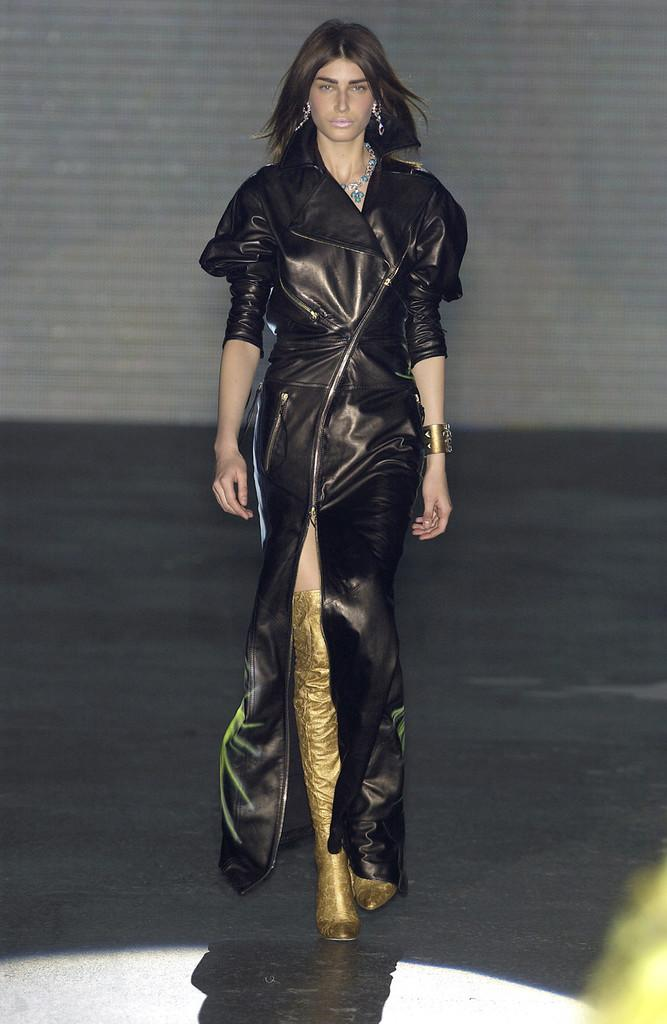Who is the main subject in the image? There is a woman in the image. What is the woman doing in the image? The woman is walking on the floor. What is the woman wearing in the image? The woman is wearing a black dress, jewelry, and golden shoes. What can be seen in the background of the image? There is a wall in the background of the image. What type of notebook is the woman holding in the image? There is no notebook present in the image. How does the woman's voice sound in the image? The image is a still photograph, so there is no sound or voice present. 